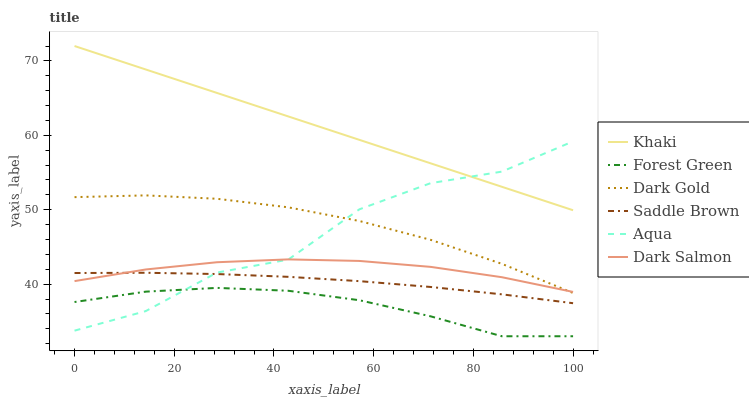Does Forest Green have the minimum area under the curve?
Answer yes or no. Yes. Does Khaki have the maximum area under the curve?
Answer yes or no. Yes. Does Dark Gold have the minimum area under the curve?
Answer yes or no. No. Does Dark Gold have the maximum area under the curve?
Answer yes or no. No. Is Khaki the smoothest?
Answer yes or no. Yes. Is Aqua the roughest?
Answer yes or no. Yes. Is Dark Gold the smoothest?
Answer yes or no. No. Is Dark Gold the roughest?
Answer yes or no. No. Does Forest Green have the lowest value?
Answer yes or no. Yes. Does Dark Gold have the lowest value?
Answer yes or no. No. Does Khaki have the highest value?
Answer yes or no. Yes. Does Dark Gold have the highest value?
Answer yes or no. No. Is Saddle Brown less than Khaki?
Answer yes or no. Yes. Is Khaki greater than Dark Salmon?
Answer yes or no. Yes. Does Aqua intersect Forest Green?
Answer yes or no. Yes. Is Aqua less than Forest Green?
Answer yes or no. No. Is Aqua greater than Forest Green?
Answer yes or no. No. Does Saddle Brown intersect Khaki?
Answer yes or no. No. 